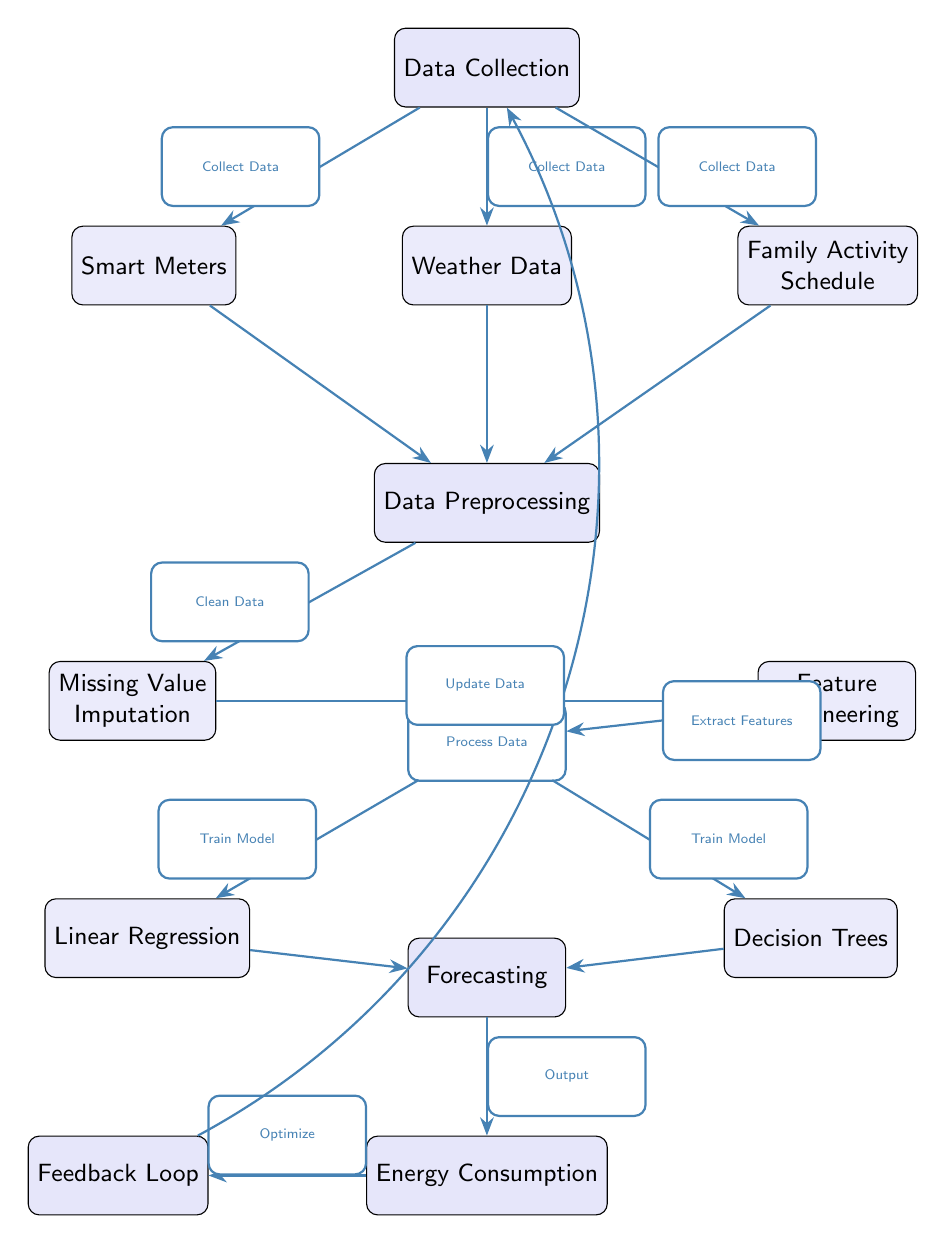What are the three data sources collected in the Data Collection node? The Data Collection node has three outgoing connections to the nodes: Smart Meters, Weather Data, and Family Activity Schedule. These represent the sources of information that will be used in the analysis.
Answer: Smart Meters, Weather Data, Family Activity Schedule How many arrows connect to the Data Preprocessing node? The Data Preprocessing node receives data from three nodes: Smart Meters, Weather Data, and Family Activity Schedule. Each connection represents a direct flow of data into Data Preprocessing, resulting in a total of three arrows.
Answer: 3 What processes occur after Data Preprocessing? After Data Preprocessing, the diagram shows a step leading to ML Models. Within this ML Models node, there are two processes: Linear Regression and Decision Trees, which are the two machine learning approaches shown in the diagram.
Answer: ML Models Which two models are trained before forecasting? The ML Models node includes two training processes: Linear Regression and Decision Trees. Both models are depicted as being trained before the output of the forecasting process occurs.
Answer: Linear Regression, Decision Trees What is the purpose of the Feedback Loop in the diagram? The Feedback Loop is designed to optimize the energy consumption predictions. It allows for an update of the data by receiving information about the energy consumption output, which then flows back to the Data Collection node, indicating that adjustments can be made based on previous forecasts.
Answer: Optimize How does data flow from Energy Consumption to Data Collection? The data flow from Energy Consumption to Data Collection is indicated by an arrow that represents the feedback mechanism. After forecasting energy consumption, the results are used to update the data, allowing for better accuracy in future predictions. This creates a cycle, improving the overall model performance.
Answer: Update Data How many main steps are in the overall process of the diagram? The diagram represents the overall process through a series of main steps: Data Collection, Data Preprocessing, ML Models, and Forecasting. Each of these steps corresponds to a major phase in the analysis workflow, leading to the final output of energy consumption which can further influence earlier steps.
Answer: 4 What is the output of the Forecasting node? The output of the Forecasting node is Energy Consumption. This node signifies the final result of the entire machine learning process designed to predict energy usage. Therefore, the output directly corresponds to the energy consumption predictions generated from the processed data.
Answer: Energy Consumption 